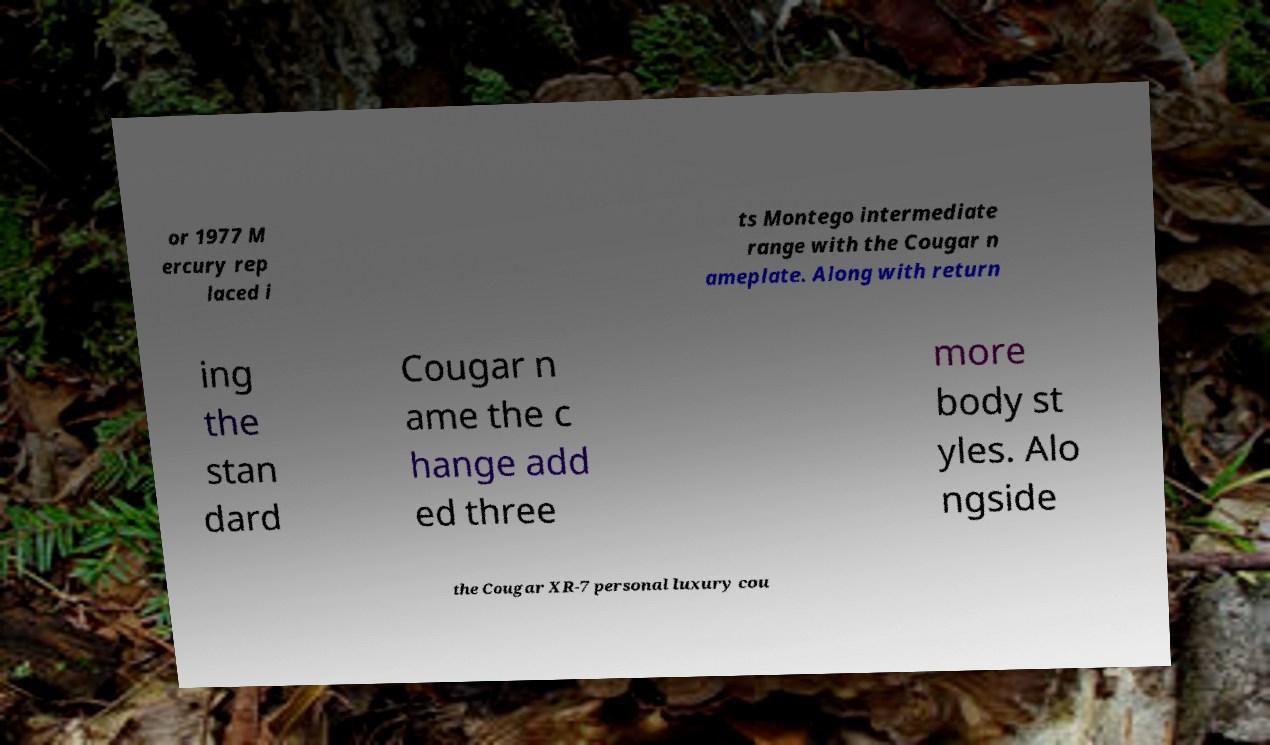There's text embedded in this image that I need extracted. Can you transcribe it verbatim? or 1977 M ercury rep laced i ts Montego intermediate range with the Cougar n ameplate. Along with return ing the stan dard Cougar n ame the c hange add ed three more body st yles. Alo ngside the Cougar XR-7 personal luxury cou 